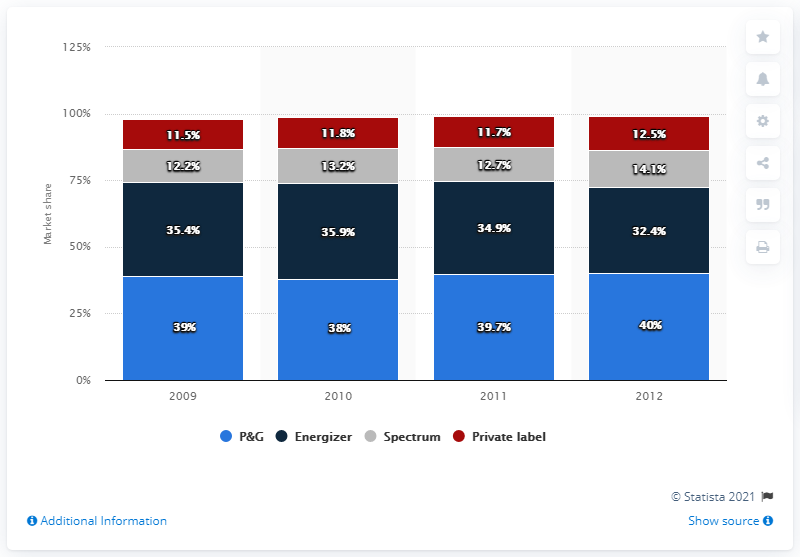Identify some key points in this picture. The highest value of navy blue bars recorded over the years is 35.9. The difference between the highest value of P&G stock over the years and the lowest value of Spectrum Health stock over the same period is 27.8%. 